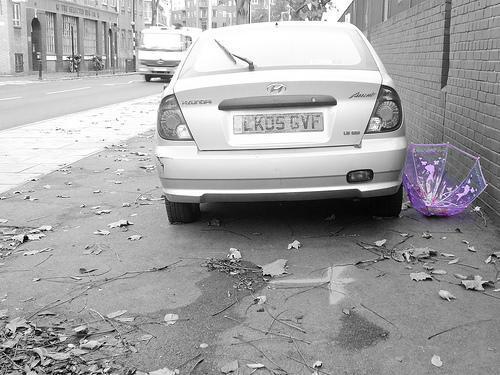How many umbrellas are there?
Give a very brief answer. 1. 